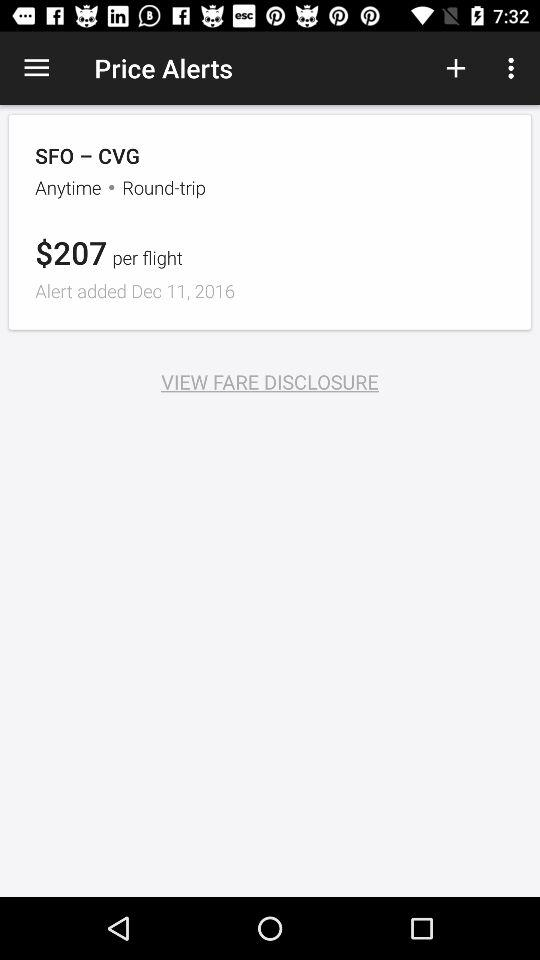How much is the round-trip fare?
Answer the question using a single word or phrase. $207 